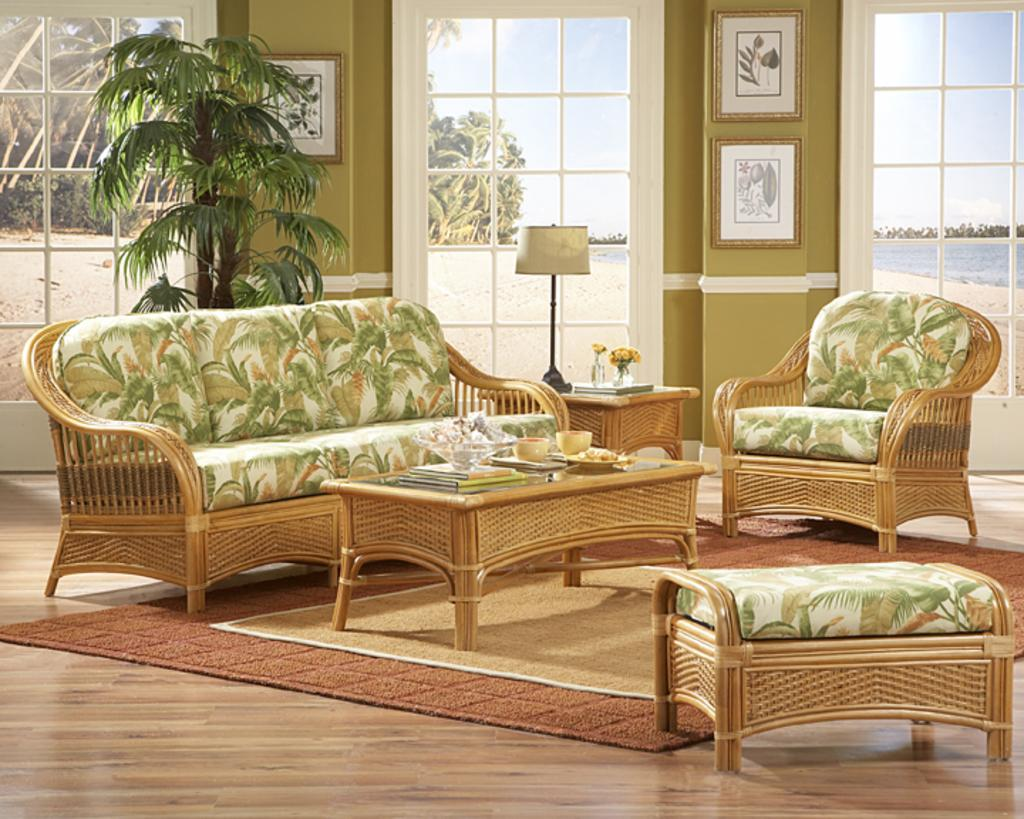What type of space is depicted in the image? The image shows an inner view of a room. What type of furniture is present in the room? There is a sofa and two chairs in the room. What is on the table in the room? There are two bowls on the table. What type of decoration is present in the room? There is a plant and photo frames on the wall. What type of lighting is present in the room? There is a lamp in the room. What month is it in the image? The image does not provide any information about the month or time of year. Can you see the ocean from the room in the image? There is no indication of an ocean or any body of water in the image. 